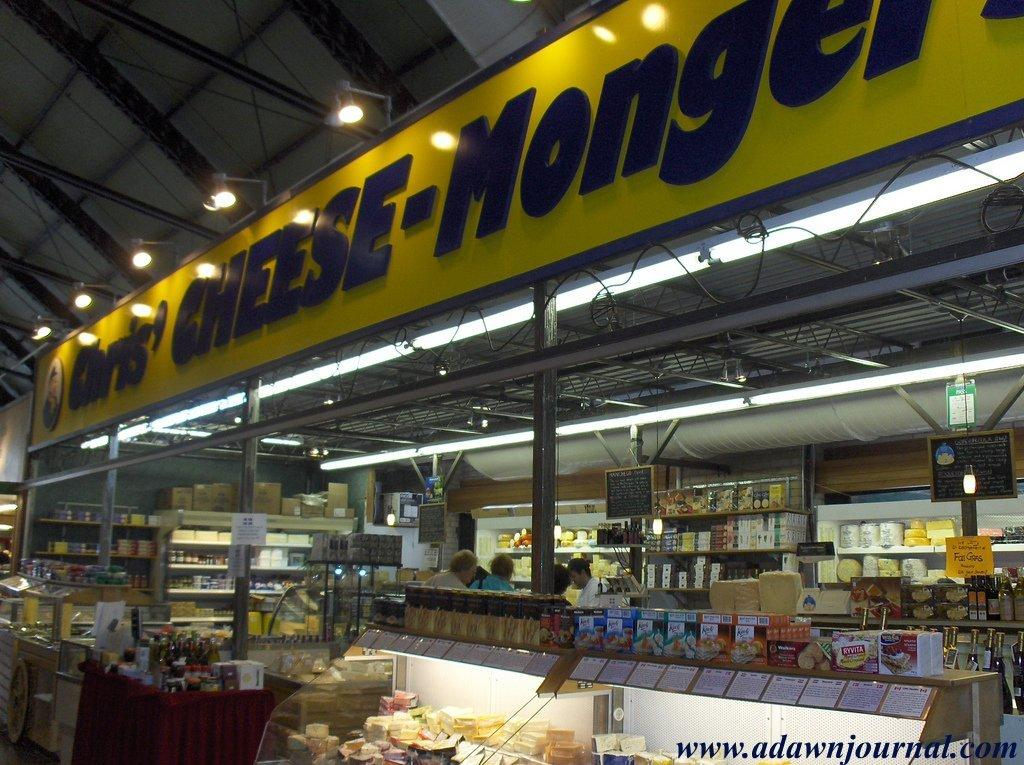<image>
Provide a brief description of the given image. A store called Chris' Cheese-Mongers has people shopping inside. 